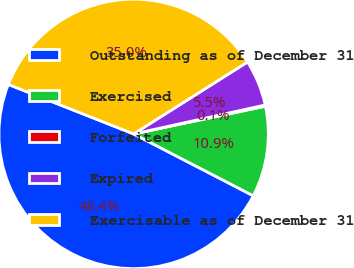<chart> <loc_0><loc_0><loc_500><loc_500><pie_chart><fcel>Outstanding as of December 31<fcel>Exercised<fcel>Forfeited<fcel>Expired<fcel>Exercisable as of December 31<nl><fcel>48.4%<fcel>10.89%<fcel>0.15%<fcel>5.52%<fcel>35.05%<nl></chart> 